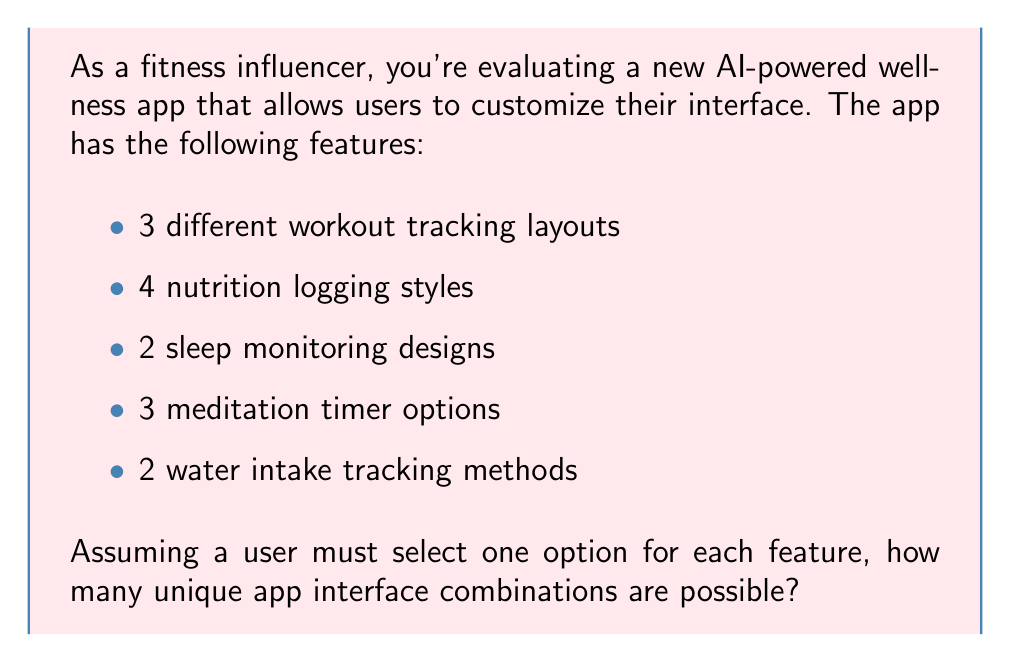Provide a solution to this math problem. To solve this problem, we need to use the multiplication principle of counting. This principle states that if we have a series of independent choices, where the number of options for each choice is fixed, the total number of possible outcomes is the product of the number of options for each choice.

Let's break down the given information:
1. Workout tracking layouts: 3 options
2. Nutrition logging styles: 4 options
3. Sleep monitoring designs: 2 options
4. Meditation timer options: 3 options
5. Water intake tracking methods: 2 options

Since a user must select one option for each feature, and the selection of one feature doesn't affect the options available for other features, we can multiply the number of options for each feature:

$$\text{Total combinations} = 3 \times 4 \times 2 \times 3 \times 2$$

Calculating this:
$$\text{Total combinations} = 3 \times 4 \times 2 \times 3 \times 2 = 144$$

Therefore, there are 144 unique app interface combinations possible.
Answer: 144 unique app interface combinations 